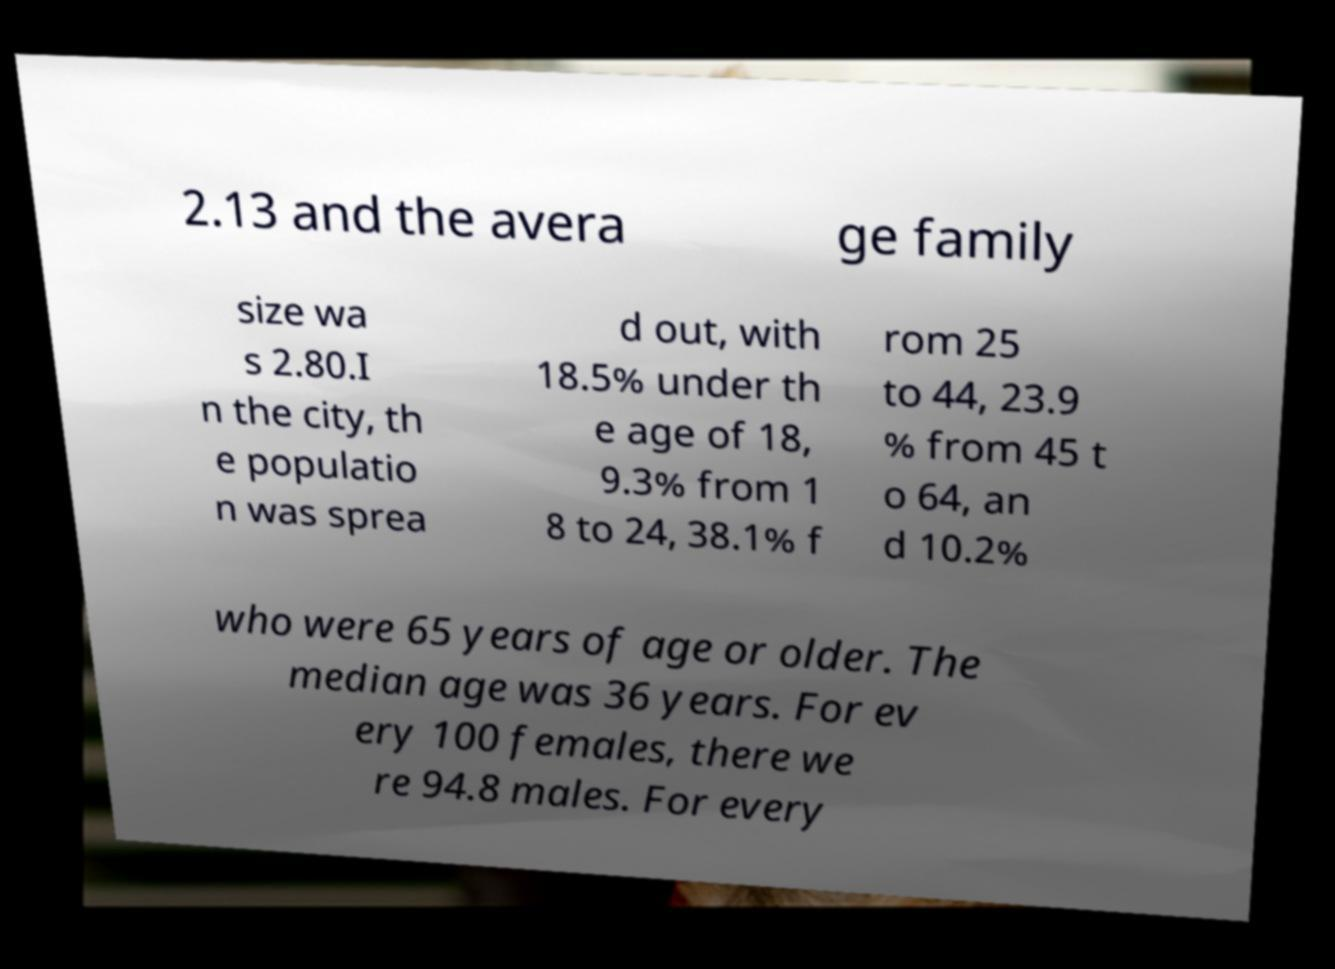What messages or text are displayed in this image? I need them in a readable, typed format. 2.13 and the avera ge family size wa s 2.80.I n the city, th e populatio n was sprea d out, with 18.5% under th e age of 18, 9.3% from 1 8 to 24, 38.1% f rom 25 to 44, 23.9 % from 45 t o 64, an d 10.2% who were 65 years of age or older. The median age was 36 years. For ev ery 100 females, there we re 94.8 males. For every 